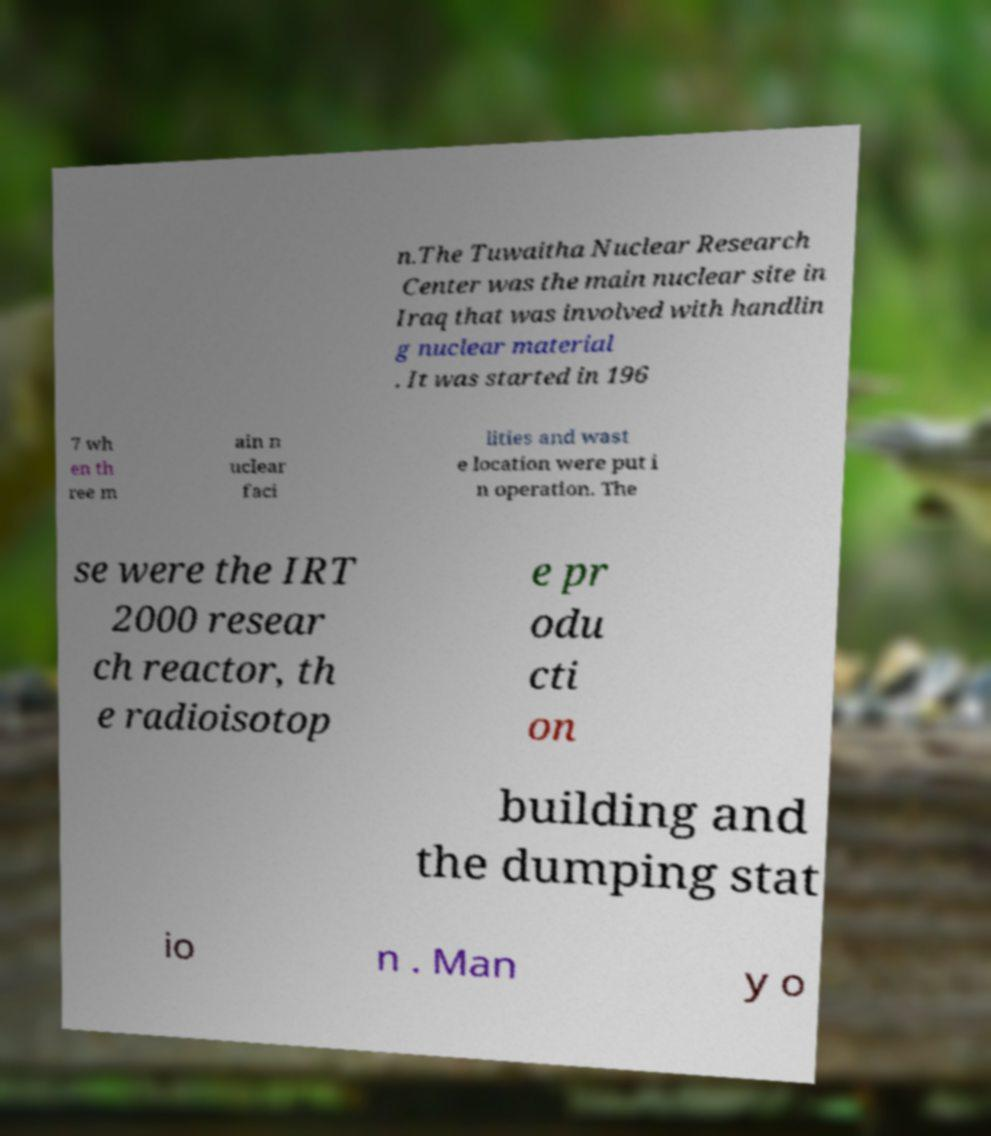Can you accurately transcribe the text from the provided image for me? n.The Tuwaitha Nuclear Research Center was the main nuclear site in Iraq that was involved with handlin g nuclear material . It was started in 196 7 wh en th ree m ain n uclear faci lities and wast e location were put i n operation. The se were the IRT 2000 resear ch reactor, th e radioisotop e pr odu cti on building and the dumping stat io n . Man y o 